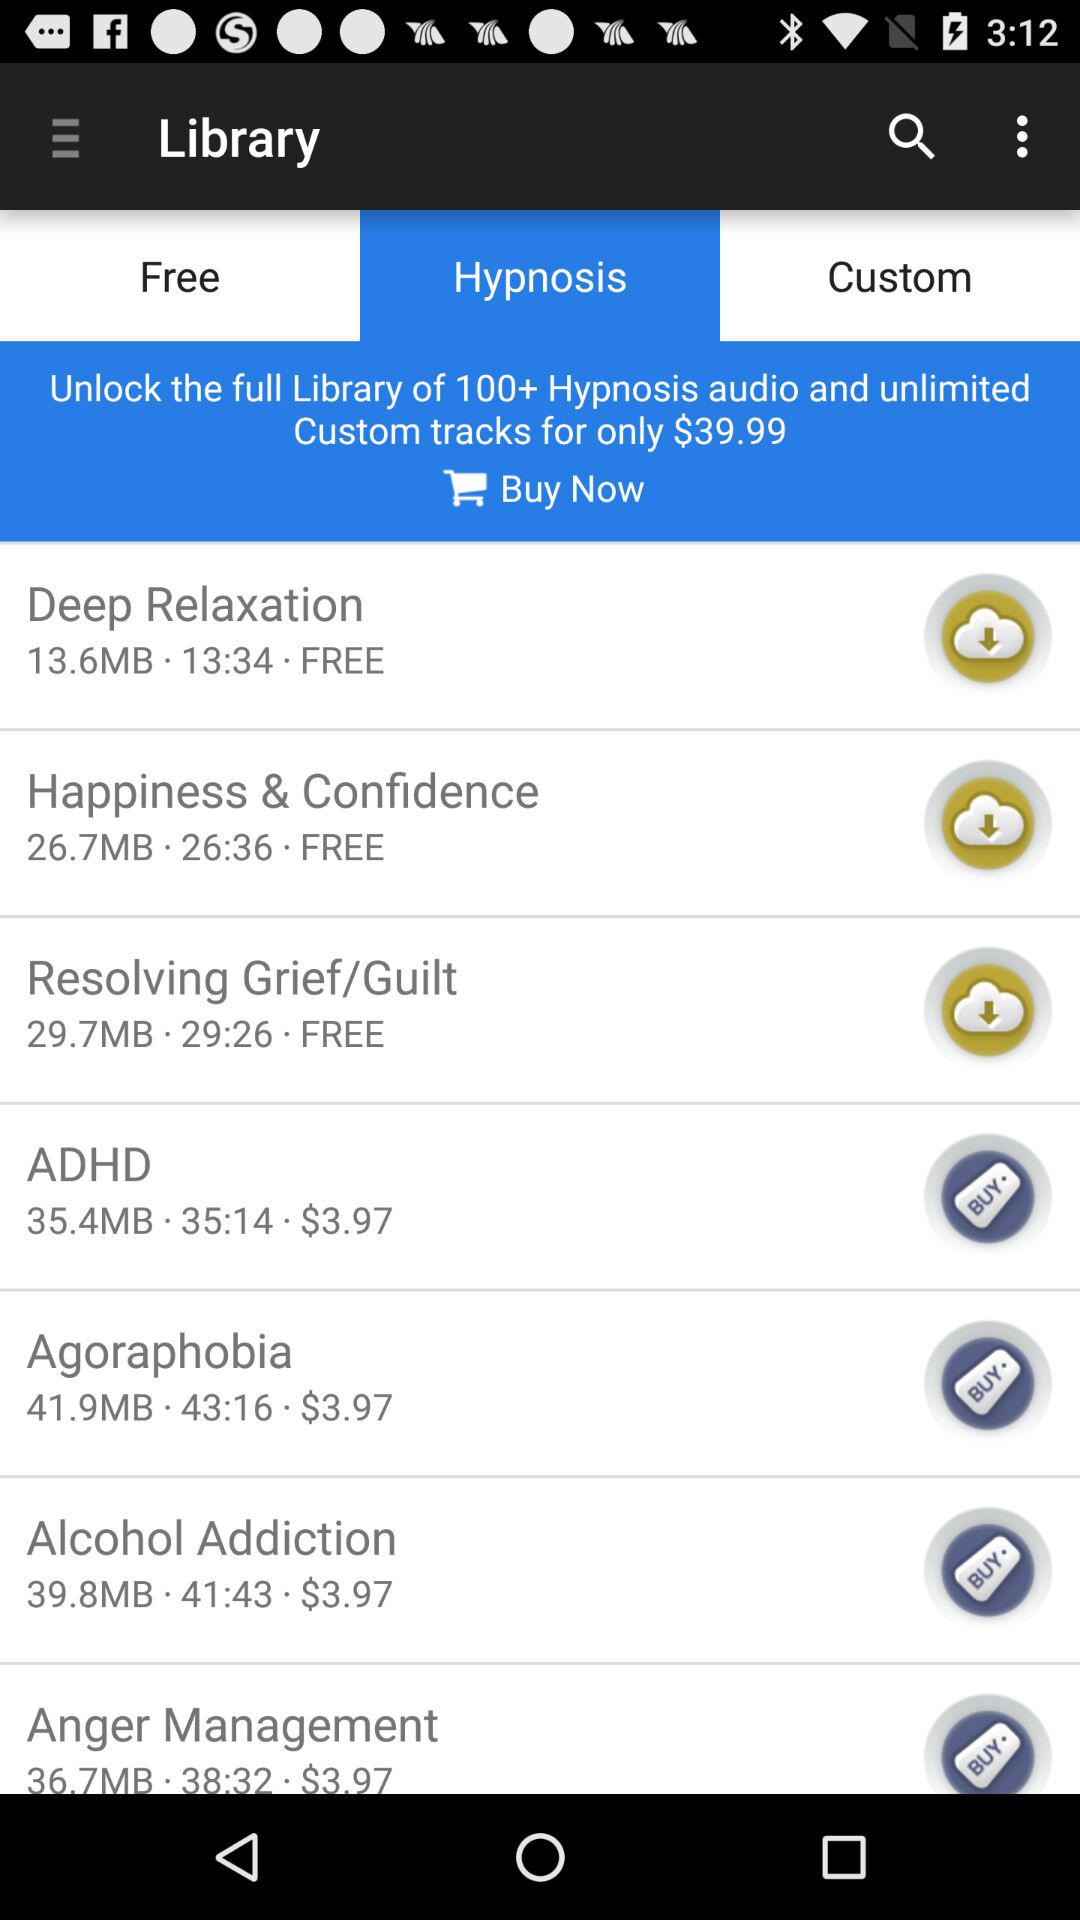What is the price of "Deep Relaxation"? "Deep Relaxation" is free. 